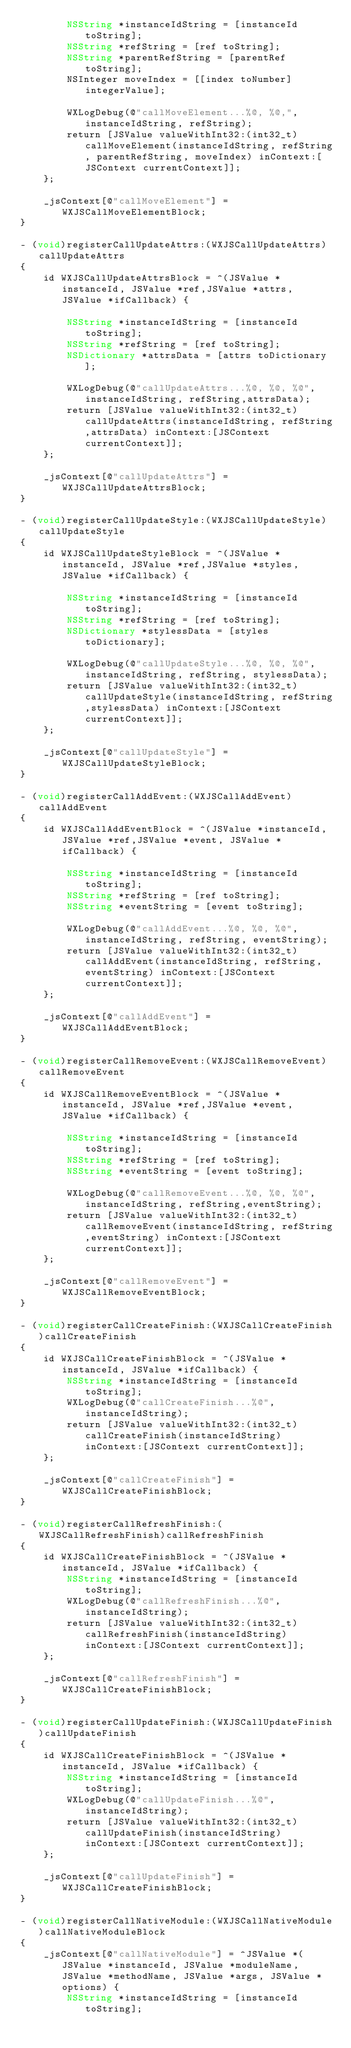Convert code to text. <code><loc_0><loc_0><loc_500><loc_500><_ObjectiveC_>        NSString *instanceIdString = [instanceId toString];
        NSString *refString = [ref toString];
        NSString *parentRefString = [parentRef toString];
        NSInteger moveIndex = [[index toNumber] integerValue];
        
        WXLogDebug(@"callMoveElement...%@, %@,", instanceIdString, refString);
        return [JSValue valueWithInt32:(int32_t)callMoveElement(instanceIdString, refString, parentRefString, moveIndex) inContext:[JSContext currentContext]];
    };
    
    _jsContext[@"callMoveElement"] = WXJSCallMoveElementBlock;
}

- (void)registerCallUpdateAttrs:(WXJSCallUpdateAttrs)callUpdateAttrs
{
    id WXJSCallUpdateAttrsBlock = ^(JSValue *instanceId, JSValue *ref,JSValue *attrs, JSValue *ifCallback) {
        
        NSString *instanceIdString = [instanceId toString];
        NSString *refString = [ref toString];
        NSDictionary *attrsData = [attrs toDictionary];
        
        WXLogDebug(@"callUpdateAttrs...%@, %@, %@", instanceIdString, refString,attrsData);
        return [JSValue valueWithInt32:(int32_t)callUpdateAttrs(instanceIdString, refString,attrsData) inContext:[JSContext currentContext]];
    };
    
    _jsContext[@"callUpdateAttrs"] = WXJSCallUpdateAttrsBlock;
}

- (void)registerCallUpdateStyle:(WXJSCallUpdateStyle)callUpdateStyle
{
    id WXJSCallUpdateStyleBlock = ^(JSValue *instanceId, JSValue *ref,JSValue *styles, JSValue *ifCallback) {
        
        NSString *instanceIdString = [instanceId toString];
        NSString *refString = [ref toString];
        NSDictionary *stylessData = [styles toDictionary];
        
        WXLogDebug(@"callUpdateStyle...%@, %@, %@", instanceIdString, refString, stylessData);
        return [JSValue valueWithInt32:(int32_t)callUpdateStyle(instanceIdString, refString,stylessData) inContext:[JSContext currentContext]];
    };
    
    _jsContext[@"callUpdateStyle"] = WXJSCallUpdateStyleBlock;
}

- (void)registerCallAddEvent:(WXJSCallAddEvent)callAddEvent
{
    id WXJSCallAddEventBlock = ^(JSValue *instanceId, JSValue *ref,JSValue *event, JSValue *ifCallback) {
        
        NSString *instanceIdString = [instanceId toString];
        NSString *refString = [ref toString];
        NSString *eventString = [event toString];
        
        WXLogDebug(@"callAddEvent...%@, %@, %@", instanceIdString, refString, eventString);
        return [JSValue valueWithInt32:(int32_t)callAddEvent(instanceIdString, refString,eventString) inContext:[JSContext currentContext]];
    };
    
    _jsContext[@"callAddEvent"] = WXJSCallAddEventBlock;
}

- (void)registerCallRemoveEvent:(WXJSCallRemoveEvent)callRemoveEvent
{
    id WXJSCallRemoveEventBlock = ^(JSValue *instanceId, JSValue *ref,JSValue *event, JSValue *ifCallback) {
        
        NSString *instanceIdString = [instanceId toString];
        NSString *refString = [ref toString];
        NSString *eventString = [event toString];
        
        WXLogDebug(@"callRemoveEvent...%@, %@, %@", instanceIdString, refString,eventString);
        return [JSValue valueWithInt32:(int32_t)callRemoveEvent(instanceIdString, refString,eventString) inContext:[JSContext currentContext]];
    };
    
    _jsContext[@"callRemoveEvent"] = WXJSCallRemoveEventBlock;
}
    
- (void)registerCallCreateFinish:(WXJSCallCreateFinish)callCreateFinish
{
    id WXJSCallCreateFinishBlock = ^(JSValue *instanceId, JSValue *ifCallback) {
        NSString *instanceIdString = [instanceId toString];
        WXLogDebug(@"callCreateFinish...%@", instanceIdString);
        return [JSValue valueWithInt32:(int32_t)callCreateFinish(instanceIdString) inContext:[JSContext currentContext]];
    };
        
    _jsContext[@"callCreateFinish"] = WXJSCallCreateFinishBlock;
}

- (void)registerCallRefreshFinish:(WXJSCallRefreshFinish)callRefreshFinish
{
    id WXJSCallCreateFinishBlock = ^(JSValue *instanceId, JSValue *ifCallback) {
        NSString *instanceIdString = [instanceId toString];
        WXLogDebug(@"callRefreshFinish...%@", instanceIdString);
        return [JSValue valueWithInt32:(int32_t)callRefreshFinish(instanceIdString) inContext:[JSContext currentContext]];
    };
    
    _jsContext[@"callRefreshFinish"] = WXJSCallCreateFinishBlock;
}

- (void)registerCallUpdateFinish:(WXJSCallUpdateFinish)callUpdateFinish
{
    id WXJSCallCreateFinishBlock = ^(JSValue *instanceId, JSValue *ifCallback) {
        NSString *instanceIdString = [instanceId toString];
        WXLogDebug(@"callUpdateFinish...%@", instanceIdString);
        return [JSValue valueWithInt32:(int32_t)callUpdateFinish(instanceIdString) inContext:[JSContext currentContext]];
    };
    
    _jsContext[@"callUpdateFinish"] = WXJSCallCreateFinishBlock;
}

- (void)registerCallNativeModule:(WXJSCallNativeModule)callNativeModuleBlock
{
    _jsContext[@"callNativeModule"] = ^JSValue *(JSValue *instanceId, JSValue *moduleName, JSValue *methodName, JSValue *args, JSValue *options) {
        NSString *instanceIdString = [instanceId toString];</code> 